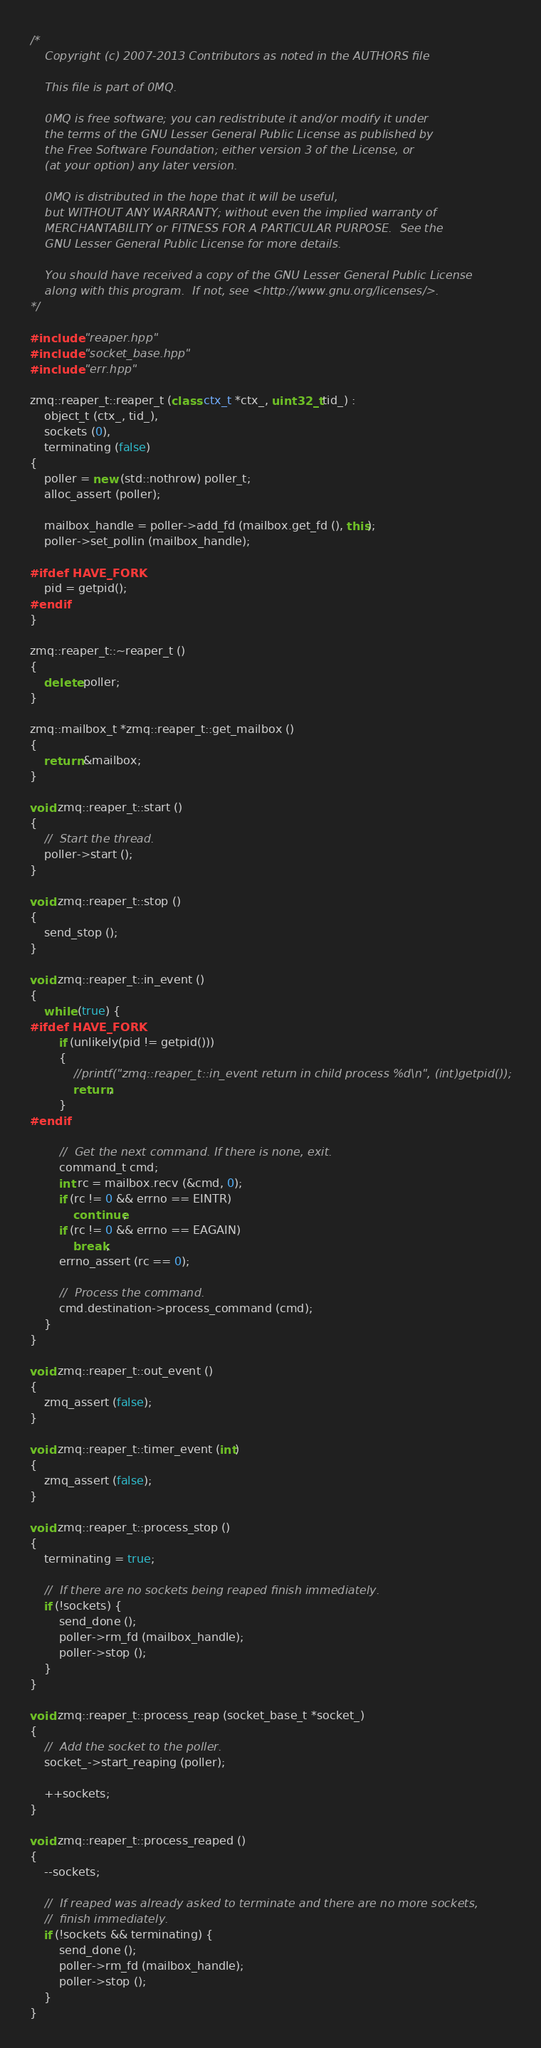<code> <loc_0><loc_0><loc_500><loc_500><_C++_>/*
    Copyright (c) 2007-2013 Contributors as noted in the AUTHORS file

    This file is part of 0MQ.

    0MQ is free software; you can redistribute it and/or modify it under
    the terms of the GNU Lesser General Public License as published by
    the Free Software Foundation; either version 3 of the License, or
    (at your option) any later version.

    0MQ is distributed in the hope that it will be useful,
    but WITHOUT ANY WARRANTY; without even the implied warranty of
    MERCHANTABILITY or FITNESS FOR A PARTICULAR PURPOSE.  See the
    GNU Lesser General Public License for more details.

    You should have received a copy of the GNU Lesser General Public License
    along with this program.  If not, see <http://www.gnu.org/licenses/>.
*/

#include "reaper.hpp"
#include "socket_base.hpp"
#include "err.hpp"

zmq::reaper_t::reaper_t (class ctx_t *ctx_, uint32_t tid_) :
    object_t (ctx_, tid_),
    sockets (0),
    terminating (false)
{
    poller = new (std::nothrow) poller_t;
    alloc_assert (poller);

    mailbox_handle = poller->add_fd (mailbox.get_fd (), this);
    poller->set_pollin (mailbox_handle);

#ifdef HAVE_FORK
    pid = getpid();
#endif
}

zmq::reaper_t::~reaper_t ()
{
    delete poller;
}

zmq::mailbox_t *zmq::reaper_t::get_mailbox ()
{
    return &mailbox;
}

void zmq::reaper_t::start ()
{
    //  Start the thread.
    poller->start ();
}

void zmq::reaper_t::stop ()
{
    send_stop ();
}

void zmq::reaper_t::in_event ()
{
    while (true) {
#ifdef HAVE_FORK
        if (unlikely(pid != getpid()))
        {
            //printf("zmq::reaper_t::in_event return in child process %d\n", (int)getpid());
            return;
        }
#endif

        //  Get the next command. If there is none, exit.
        command_t cmd;
        int rc = mailbox.recv (&cmd, 0);
        if (rc != 0 && errno == EINTR)
            continue;
        if (rc != 0 && errno == EAGAIN)
            break;
        errno_assert (rc == 0);

        //  Process the command.
        cmd.destination->process_command (cmd);
    }
}

void zmq::reaper_t::out_event ()
{
    zmq_assert (false);
}

void zmq::reaper_t::timer_event (int)
{
    zmq_assert (false);
}

void zmq::reaper_t::process_stop ()
{
    terminating = true;

    //  If there are no sockets being reaped finish immediately.
    if (!sockets) {
        send_done ();
        poller->rm_fd (mailbox_handle);
        poller->stop ();
    }
}

void zmq::reaper_t::process_reap (socket_base_t *socket_)
{
    //  Add the socket to the poller.
    socket_->start_reaping (poller);

    ++sockets;
}

void zmq::reaper_t::process_reaped ()
{
    --sockets;

    //  If reaped was already asked to terminate and there are no more sockets,
    //  finish immediately.
    if (!sockets && terminating) {
        send_done ();
        poller->rm_fd (mailbox_handle);
        poller->stop ();
    }
}
</code> 